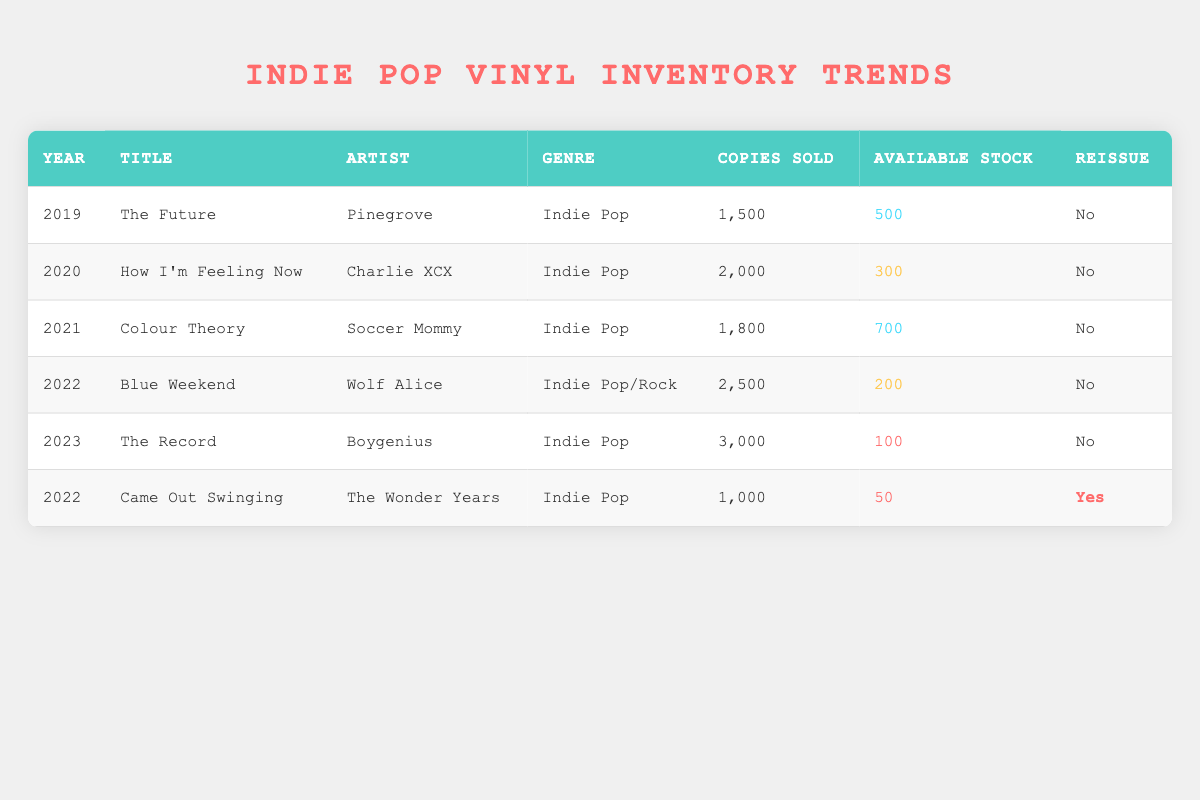What was the highest number of copies sold for a vinyl record in the table? By reviewing the "Copies Sold" column, we see that the highest number is 3000 for the album "The Record" by Boygenius in 2023.
Answer: 3000 Which artist had the lowest available stock in the table? Looking at the "Available Stock" column, the lowest stock is 50 for "Came Out Swinging" by The Wonder Years in 2022.
Answer: The Wonder Years How many total copies were sold for all the albums listed in the table? Adding up the "Copies Sold" values: 1500 + 2000 + 1800 + 2500 + 3000 + 1000 = 11800 total copies sold.
Answer: 11800 Were there any reissued albums in the data? Checking the "Reissue" column, we find that "Came Out Swinging" by The Wonder Years in 2022 is the only album marked Yes.
Answer: Yes What is the average available stock across all albums in the table? First, we sum the available stocks: 500 + 300 + 700 + 200 + 100 + 50 = 1850. Since there are six albums, we calculate the average: 1850 / 6 ≈ 308.33.
Answer: Approximately 308.33 Which year had the most copies sold, and how many were sold? Examining the "Year" and "Copies Sold" columns, 2023 had the most copies sold with 3000.
Answer: 2023, 3000 Did any album have more copies sold than available stock? Analyzing the data, we see that "How I'm Feeling Now" by Charlie XCX sold 2000 copies while having 300 available. Similarly, "Blue Weekend" by Wolf Alice sold 2500 with only 200 available stock.
Answer: Yes What is the difference in copies sold between the highest and the lowest selling albums? The highest selling album is "The Record" with 3000 copies, and the lowest is "Came Out Swinging" with 1000 copies. Therefore, the difference is 3000 - 1000 = 2000.
Answer: 2000 In which year did the album with the highest available stock release? The album with the highest available stock is "Colour Theory" with 700 available stock, released in 2021.
Answer: 2021 